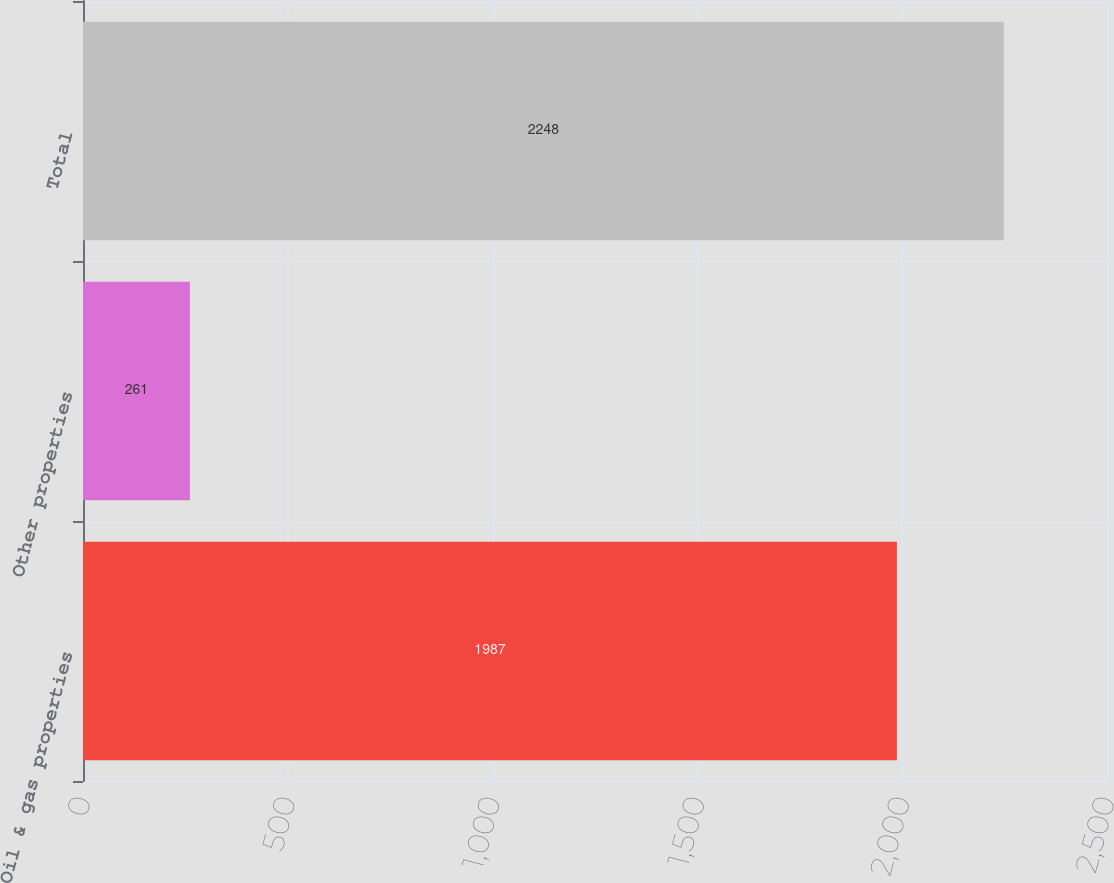<chart> <loc_0><loc_0><loc_500><loc_500><bar_chart><fcel>Oil & gas properties<fcel>Other properties<fcel>Total<nl><fcel>1987<fcel>261<fcel>2248<nl></chart> 